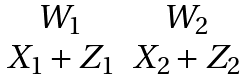<formula> <loc_0><loc_0><loc_500><loc_500>\begin{matrix} W _ { 1 } & W _ { 2 } \\ X _ { 1 } + Z _ { 1 } & X _ { 2 } + Z _ { 2 } \end{matrix}</formula> 